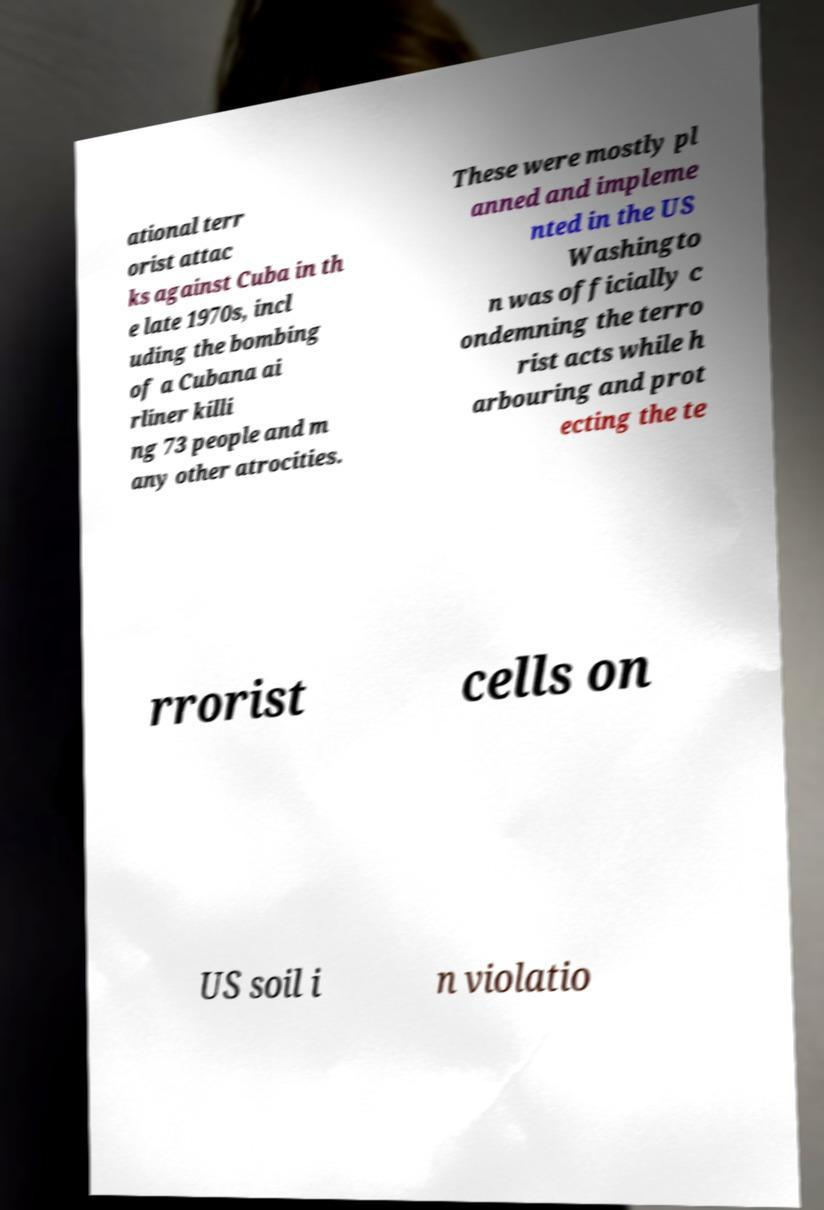Please read and relay the text visible in this image. What does it say? ational terr orist attac ks against Cuba in th e late 1970s, incl uding the bombing of a Cubana ai rliner killi ng 73 people and m any other atrocities. These were mostly pl anned and impleme nted in the US Washingto n was officially c ondemning the terro rist acts while h arbouring and prot ecting the te rrorist cells on US soil i n violatio 